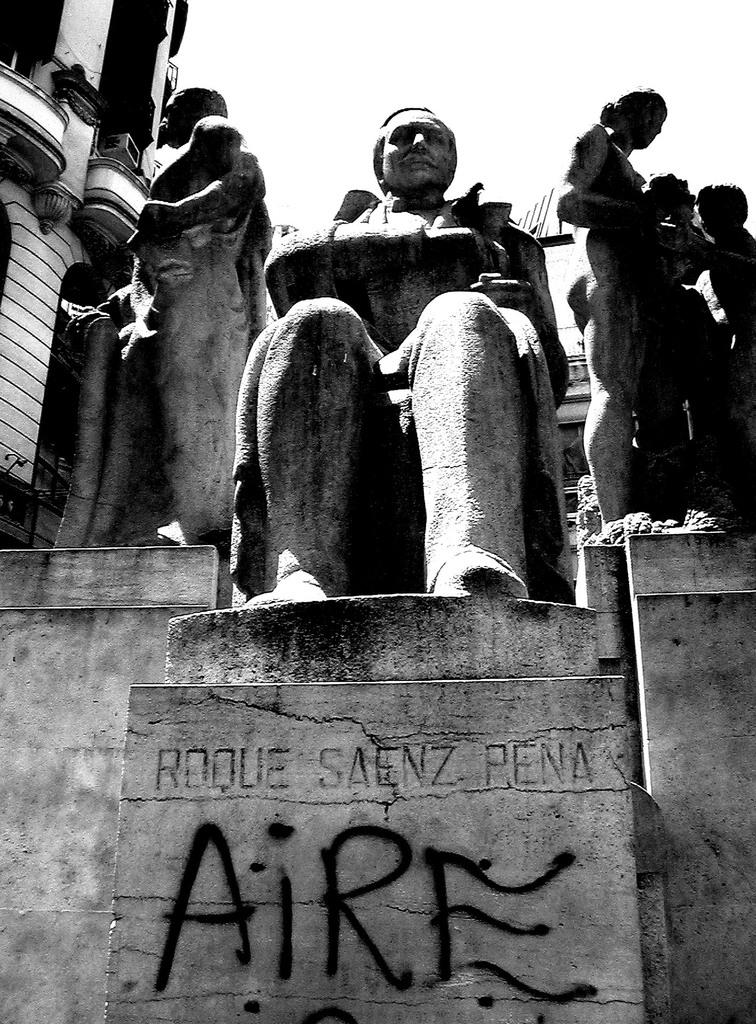What type of artwork can be seen in the image? There are sculptures in the image. What else is present on the wall with the sculptures? There is text on a wall in the image. What structure is visible on the left side of the image? There is a building visible on the left side of the image. What is visible at the top of the image? The sky is visible at the top of the image. Can you see the moon in the image? The moon is not present in the image; only the sculptures, text on the wall, building, and sky are visible. How many hens are depicted in the image? There are no hens present in the image. 